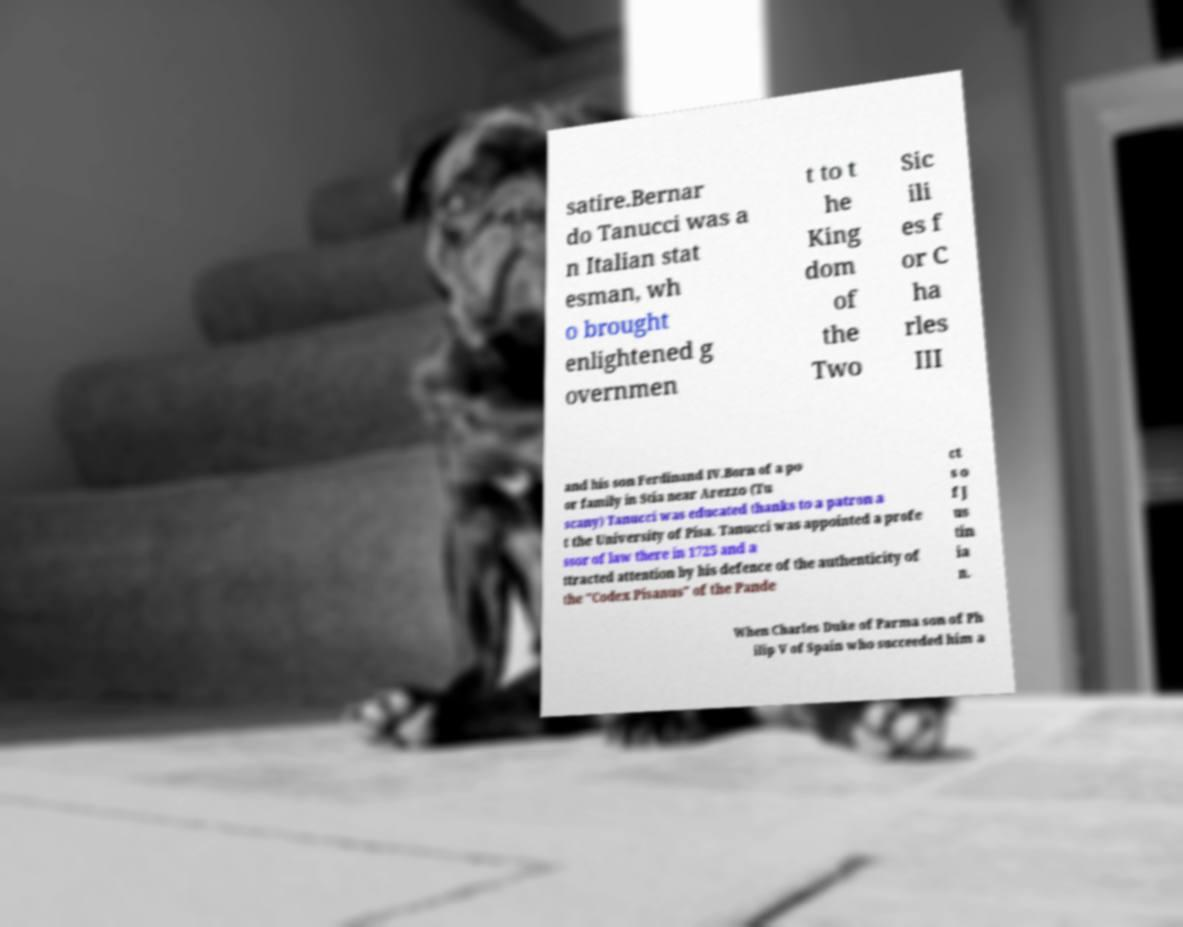Can you read and provide the text displayed in the image?This photo seems to have some interesting text. Can you extract and type it out for me? satire.Bernar do Tanucci was a n Italian stat esman, wh o brought enlightened g overnmen t to t he King dom of the Two Sic ili es f or C ha rles III and his son Ferdinand IV.Born of a po or family in Stia near Arezzo (Tu scany) Tanucci was educated thanks to a patron a t the University of Pisa. Tanucci was appointed a profe ssor of law there in 1725 and a ttracted attention by his defence of the authenticity of the "Codex Pisanus" of the Pande ct s o f J us tin ia n. When Charles Duke of Parma son of Ph ilip V of Spain who succeeded him a 